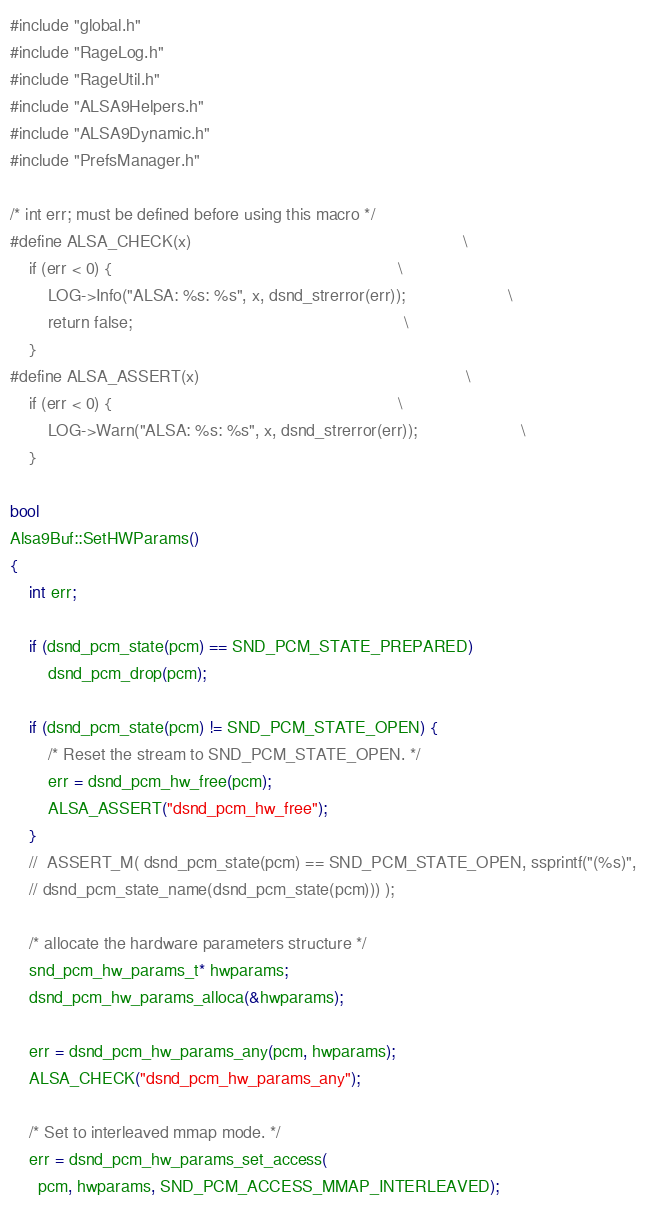<code> <loc_0><loc_0><loc_500><loc_500><_C++_>#include "global.h"
#include "RageLog.h"
#include "RageUtil.h"
#include "ALSA9Helpers.h"
#include "ALSA9Dynamic.h"
#include "PrefsManager.h"

/* int err; must be defined before using this macro */
#define ALSA_CHECK(x)                                                          \
	if (err < 0) {                                                             \
		LOG->Info("ALSA: %s: %s", x, dsnd_strerror(err));                      \
		return false;                                                          \
	}
#define ALSA_ASSERT(x)                                                         \
	if (err < 0) {                                                             \
		LOG->Warn("ALSA: %s: %s", x, dsnd_strerror(err));                      \
	}

bool
Alsa9Buf::SetHWParams()
{
	int err;

	if (dsnd_pcm_state(pcm) == SND_PCM_STATE_PREPARED)
		dsnd_pcm_drop(pcm);

	if (dsnd_pcm_state(pcm) != SND_PCM_STATE_OPEN) {
		/* Reset the stream to SND_PCM_STATE_OPEN. */
		err = dsnd_pcm_hw_free(pcm);
		ALSA_ASSERT("dsnd_pcm_hw_free");
	}
	//	ASSERT_M( dsnd_pcm_state(pcm) == SND_PCM_STATE_OPEN, ssprintf("(%s)",
	// dsnd_pcm_state_name(dsnd_pcm_state(pcm))) );

	/* allocate the hardware parameters structure */
	snd_pcm_hw_params_t* hwparams;
	dsnd_pcm_hw_params_alloca(&hwparams);

	err = dsnd_pcm_hw_params_any(pcm, hwparams);
	ALSA_CHECK("dsnd_pcm_hw_params_any");

	/* Set to interleaved mmap mode. */
	err = dsnd_pcm_hw_params_set_access(
	  pcm, hwparams, SND_PCM_ACCESS_MMAP_INTERLEAVED);</code> 